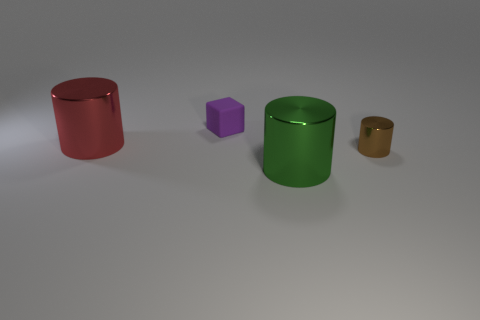The object that is right of the large red metallic thing and left of the green shiny object is made of what material?
Give a very brief answer. Rubber. Are there any tiny gray balls?
Your answer should be compact. No. There is a small rubber thing; is it the same color as the large shiny cylinder that is on the left side of the purple block?
Make the answer very short. No. Is there anything else that is the same shape as the rubber object?
Your response must be concise. No. There is a small thing in front of the large red metal cylinder that is to the left of the large shiny cylinder in front of the red cylinder; what is its shape?
Your response must be concise. Cylinder. What is the shape of the green object?
Keep it short and to the point. Cylinder. What is the color of the big metallic object to the left of the block?
Provide a succinct answer. Red. There is a cylinder on the left side of the green cylinder; is it the same size as the tiny cylinder?
Provide a short and direct response. No. The brown metallic thing that is the same shape as the large red object is what size?
Ensure brevity in your answer.  Small. Does the green object have the same shape as the brown metal thing?
Your answer should be very brief. Yes. 